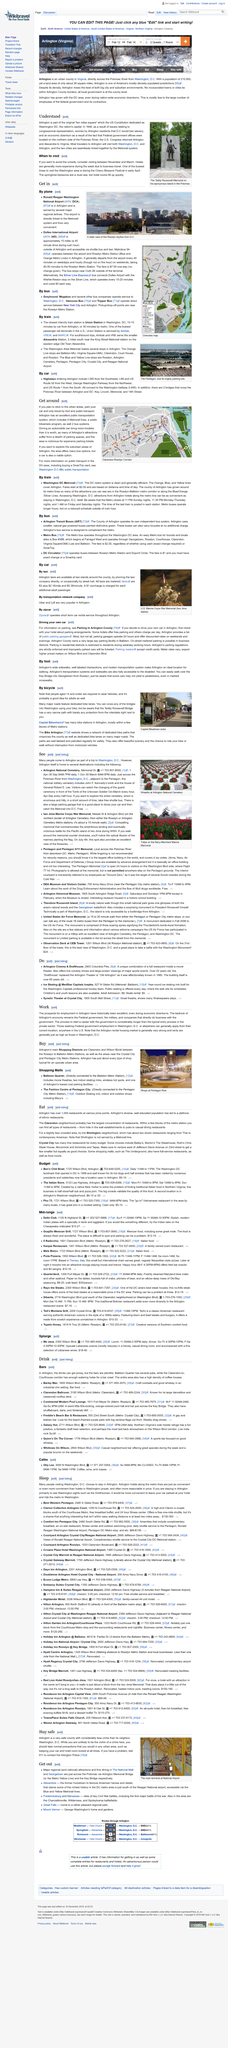Draw attention to some important aspects in this diagram. The Arlington Cherry Blossom Festival is an annual event that takes place in early April. The best time to visit Arlington to avoid the crowds is between November and March. The Metrorail system provides a direct link between Arlington and Washington D.C., enabling passengers to easily travel between the two locations. 